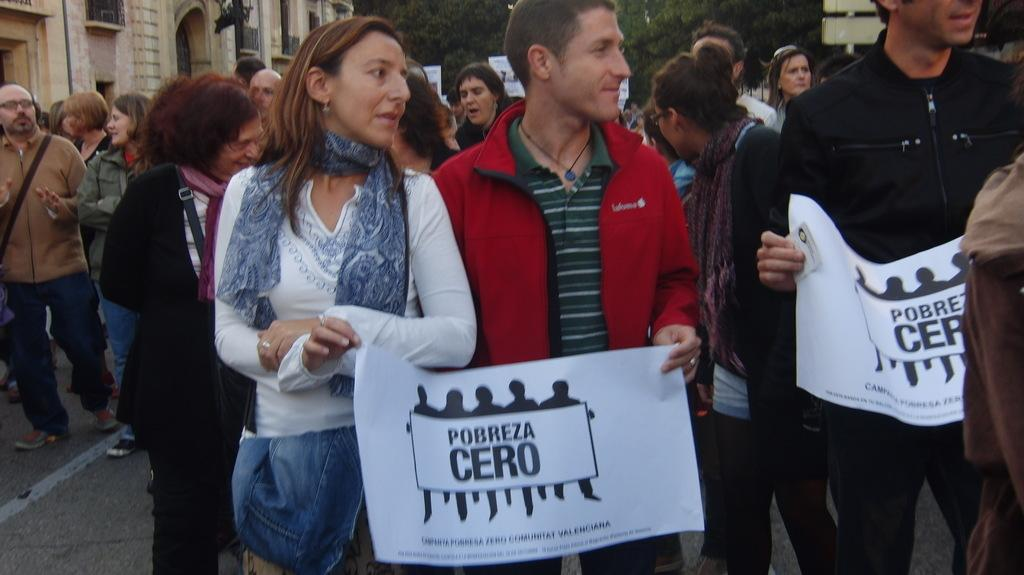How many people are in the image? There are persons in the image, but the exact number is not specified. What are some of the persons holding in the image? Some of the persons are holding posters in the image. What can be found on the posters? There is text on the posters. What type of cast is visible on the grandfather's arm in the image? There is no grandfather or cast present in the image. How many family members are visible in the image? The number of family members in the image is not specified, as the term "family" is not mentioned in the provided facts. 